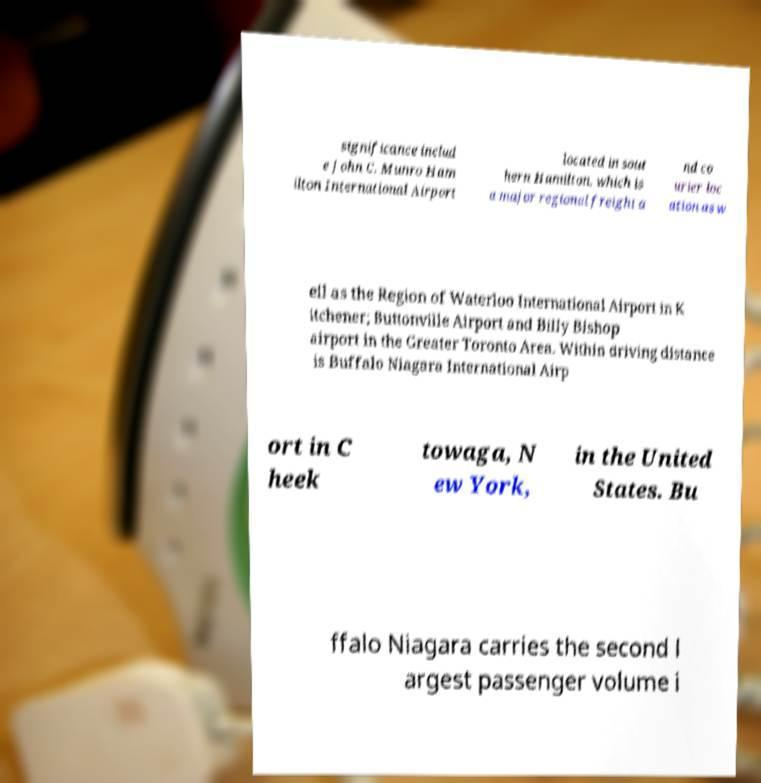Can you accurately transcribe the text from the provided image for me? significance includ e John C. Munro Ham ilton International Airport located in sout hern Hamilton, which is a major regional freight a nd co urier loc ation as w ell as the Region of Waterloo International Airport in K itchener; Buttonville Airport and Billy Bishop airport in the Greater Toronto Area. Within driving distance is Buffalo Niagara International Airp ort in C heek towaga, N ew York, in the United States. Bu ffalo Niagara carries the second l argest passenger volume i 